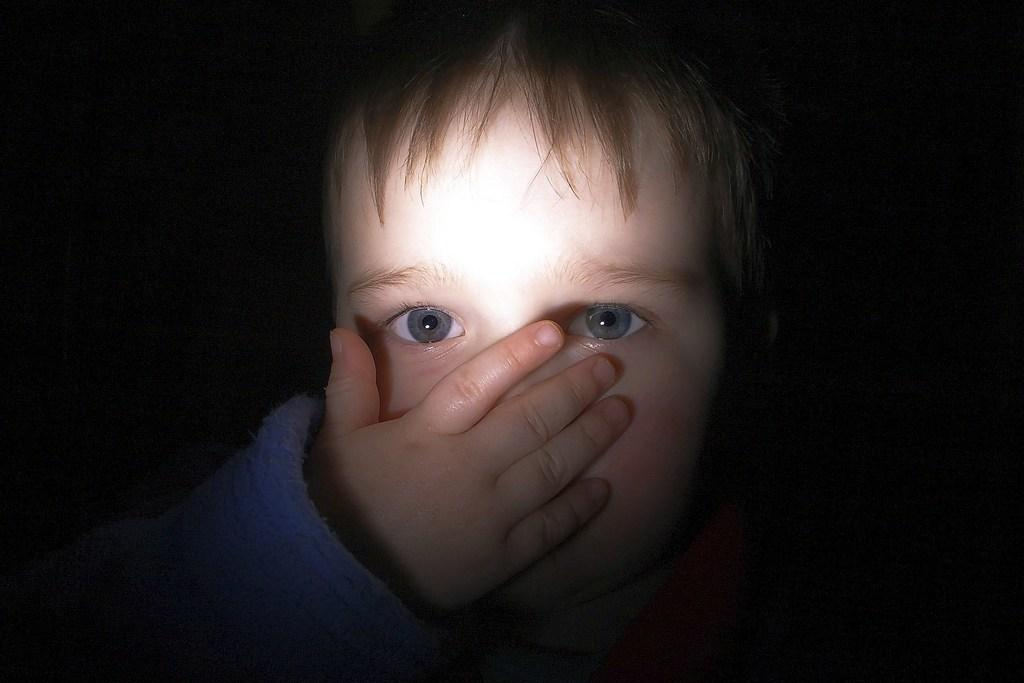What is the main subject of the picture? The main subject of the picture is a baby. Can you describe the background of the image? The background of the image is completely dark. What type of government is depicted in the image? There is no depiction of a government in the image; it features a baby in the middle of the picture with a dark background. What is the baby holding in the image? The provided facts do not mention anything the baby is holding, so it cannot be determined from the image. 